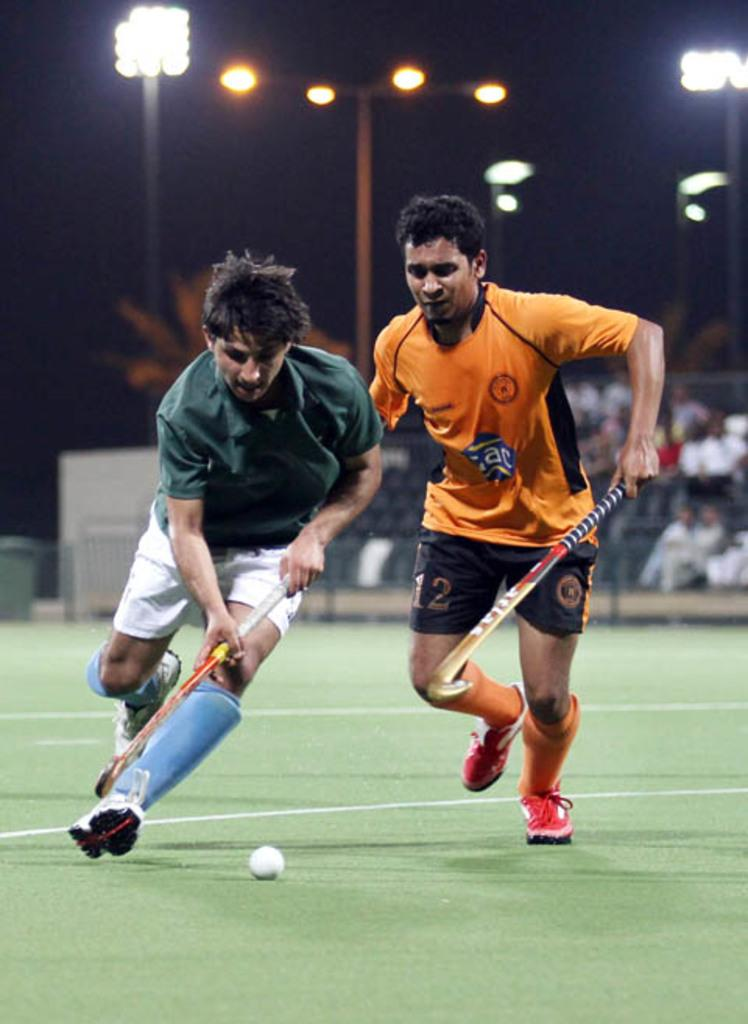<image>
Share a concise interpretation of the image provided. a couple players playing field hockey one with the num\ber 12 